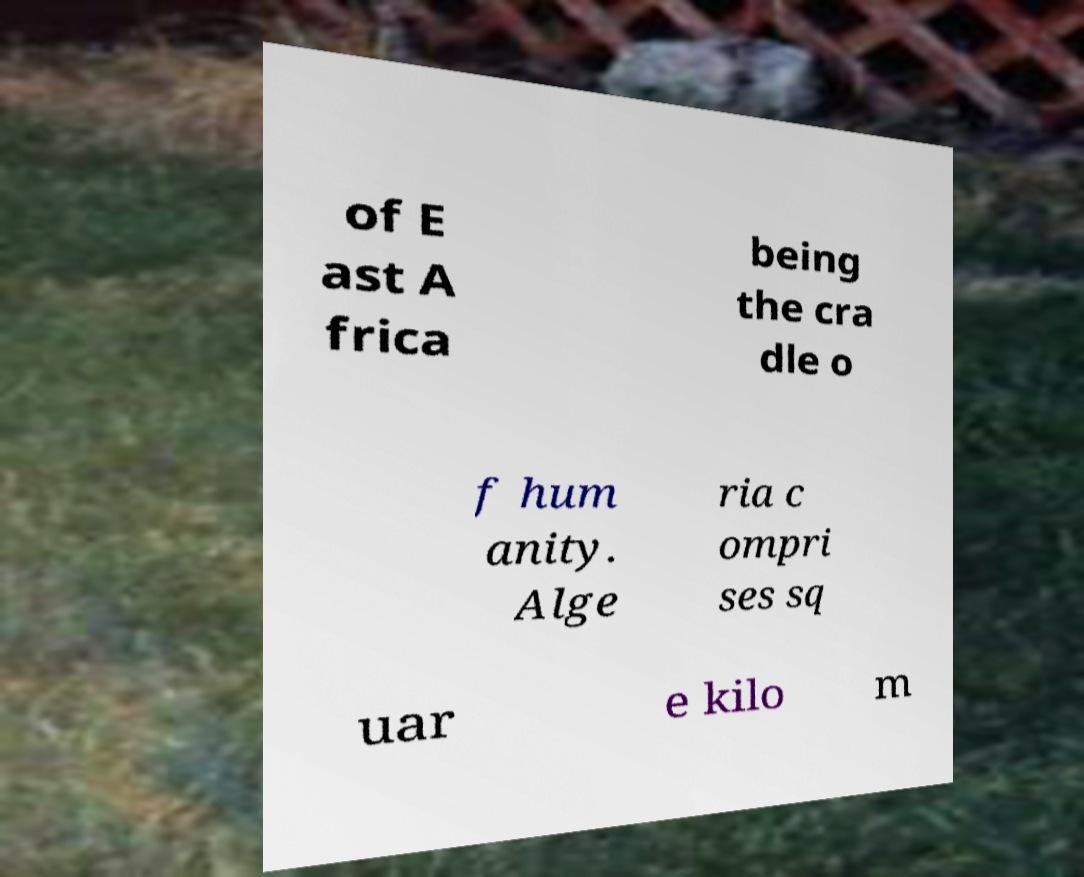Can you accurately transcribe the text from the provided image for me? of E ast A frica being the cra dle o f hum anity. Alge ria c ompri ses sq uar e kilo m 